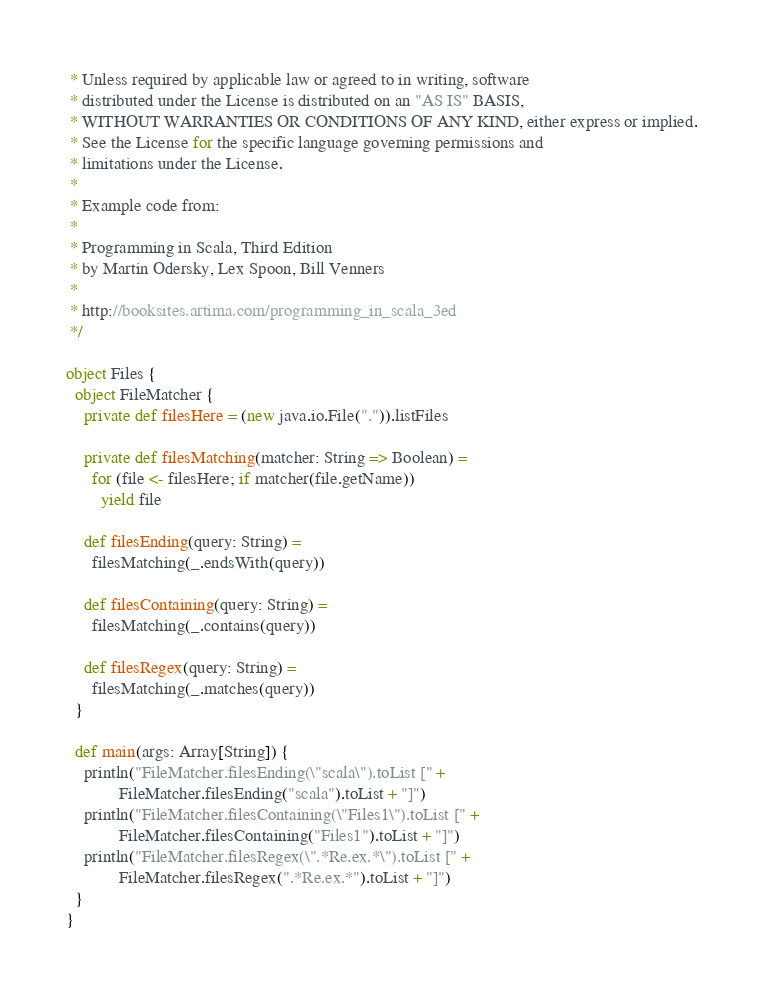<code> <loc_0><loc_0><loc_500><loc_500><_Scala_> * Unless required by applicable law or agreed to in writing, software
 * distributed under the License is distributed on an "AS IS" BASIS,
 * WITHOUT WARRANTIES OR CONDITIONS OF ANY KIND, either express or implied.
 * See the License for the specific language governing permissions and
 * limitations under the License.
 *
 * Example code from:
 *
 * Programming in Scala, Third Edition
 * by Martin Odersky, Lex Spoon, Bill Venners
 *
 * http://booksites.artima.com/programming_in_scala_3ed
 */

object Files {
  object FileMatcher {
    private def filesHere = (new java.io.File(".")).listFiles
  
    private def filesMatching(matcher: String => Boolean) =
      for (file <- filesHere; if matcher(file.getName))
        yield file
  
    def filesEnding(query: String) =
      filesMatching(_.endsWith(query))
  
    def filesContaining(query: String) =
      filesMatching(_.contains(query))
  
    def filesRegex(query: String) =
      filesMatching(_.matches(query))
  }

  def main(args: Array[String]) {
    println("FileMatcher.filesEnding(\"scala\").toList [" +
            FileMatcher.filesEnding("scala").toList + "]")
    println("FileMatcher.filesContaining(\"Files1\").toList [" + 
            FileMatcher.filesContaining("Files1").toList + "]")
    println("FileMatcher.filesRegex(\".*Re.ex.*\").toList [" + 
            FileMatcher.filesRegex(".*Re.ex.*").toList + "]")
  }
}

</code> 